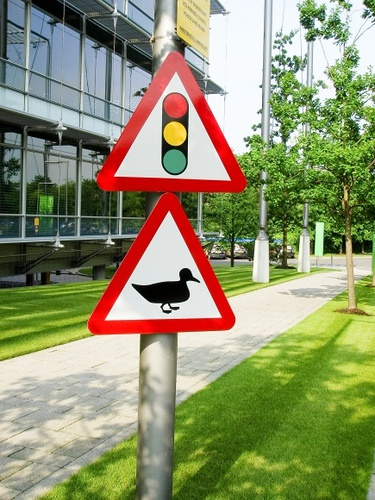Describe the objects in this image and their specific colors. I can see traffic light in blue, black, salmon, teal, and gold tones, car in blue, gray, darkgray, and lightgray tones, car in blue, gray, darkgray, beige, and darkgreen tones, and car in blue, gray, black, darkgray, and ivory tones in this image. 